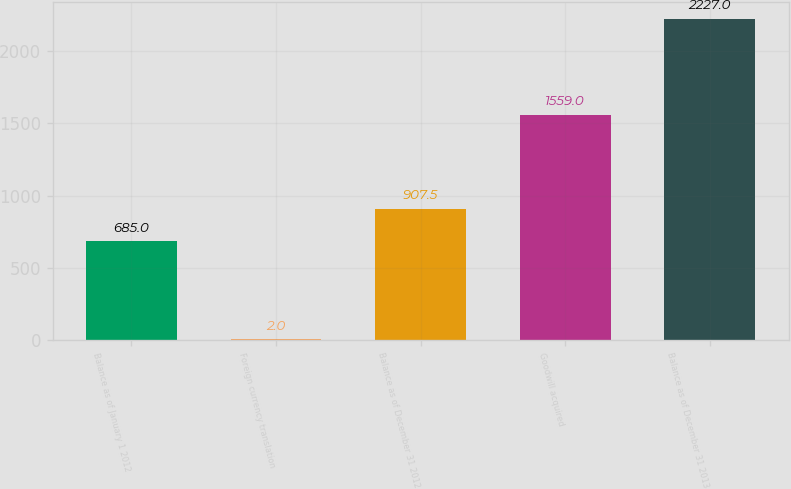<chart> <loc_0><loc_0><loc_500><loc_500><bar_chart><fcel>Balance as of January 1 2012<fcel>Foreign currency translation<fcel>Balance as of December 31 2012<fcel>Goodwill acquired<fcel>Balance as of December 31 2013<nl><fcel>685<fcel>2<fcel>907.5<fcel>1559<fcel>2227<nl></chart> 